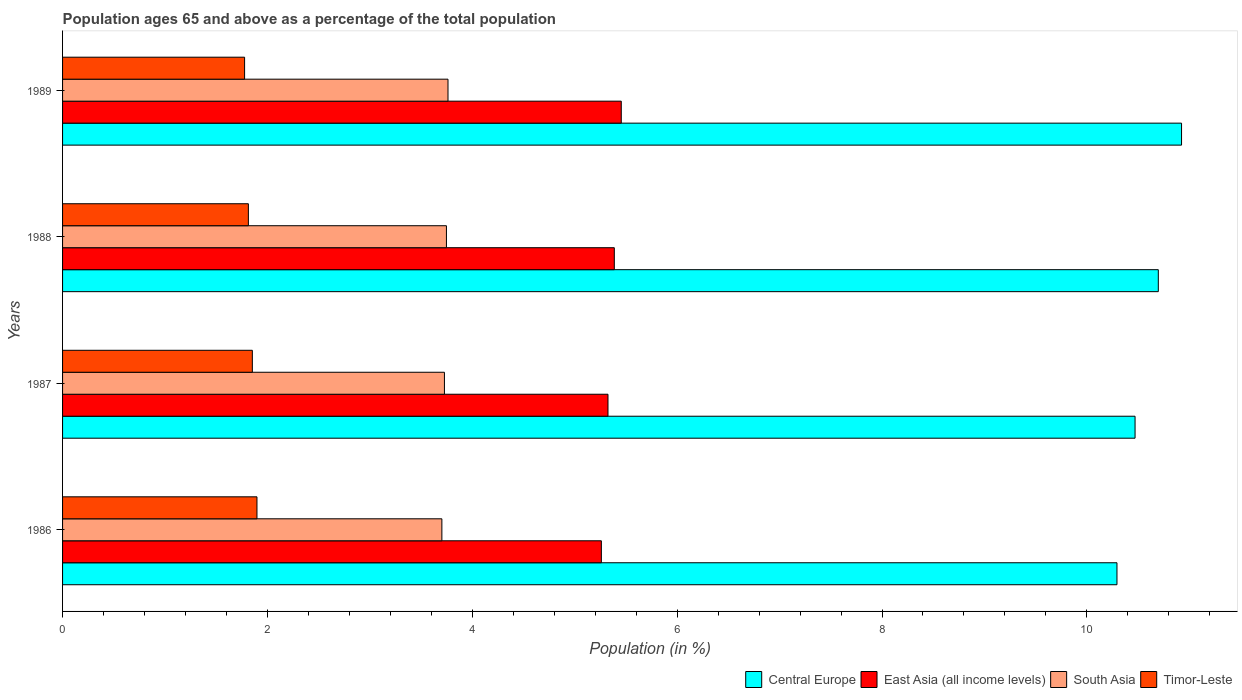How many groups of bars are there?
Your answer should be very brief. 4. Are the number of bars per tick equal to the number of legend labels?
Your response must be concise. Yes. Are the number of bars on each tick of the Y-axis equal?
Offer a very short reply. Yes. How many bars are there on the 2nd tick from the bottom?
Offer a terse response. 4. In how many cases, is the number of bars for a given year not equal to the number of legend labels?
Keep it short and to the point. 0. What is the percentage of the population ages 65 and above in Central Europe in 1988?
Offer a terse response. 10.7. Across all years, what is the maximum percentage of the population ages 65 and above in East Asia (all income levels)?
Your answer should be compact. 5.45. Across all years, what is the minimum percentage of the population ages 65 and above in South Asia?
Ensure brevity in your answer.  3.7. What is the total percentage of the population ages 65 and above in South Asia in the graph?
Provide a succinct answer. 14.94. What is the difference between the percentage of the population ages 65 and above in Central Europe in 1988 and that in 1989?
Offer a very short reply. -0.23. What is the difference between the percentage of the population ages 65 and above in South Asia in 1988 and the percentage of the population ages 65 and above in East Asia (all income levels) in 1986?
Ensure brevity in your answer.  -1.51. What is the average percentage of the population ages 65 and above in Central Europe per year?
Offer a very short reply. 10.6. In the year 1987, what is the difference between the percentage of the population ages 65 and above in South Asia and percentage of the population ages 65 and above in Central Europe?
Your response must be concise. -6.74. In how many years, is the percentage of the population ages 65 and above in East Asia (all income levels) greater than 6.8 ?
Provide a succinct answer. 0. What is the ratio of the percentage of the population ages 65 and above in East Asia (all income levels) in 1987 to that in 1989?
Give a very brief answer. 0.98. What is the difference between the highest and the second highest percentage of the population ages 65 and above in South Asia?
Your answer should be compact. 0.02. What is the difference between the highest and the lowest percentage of the population ages 65 and above in East Asia (all income levels)?
Keep it short and to the point. 0.19. In how many years, is the percentage of the population ages 65 and above in East Asia (all income levels) greater than the average percentage of the population ages 65 and above in East Asia (all income levels) taken over all years?
Your response must be concise. 2. What does the 1st bar from the bottom in 1987 represents?
Your answer should be very brief. Central Europe. Is it the case that in every year, the sum of the percentage of the population ages 65 and above in South Asia and percentage of the population ages 65 and above in East Asia (all income levels) is greater than the percentage of the population ages 65 and above in Timor-Leste?
Make the answer very short. Yes. How many years are there in the graph?
Provide a succinct answer. 4. What is the difference between two consecutive major ticks on the X-axis?
Ensure brevity in your answer.  2. Does the graph contain grids?
Keep it short and to the point. No. Where does the legend appear in the graph?
Your response must be concise. Bottom right. What is the title of the graph?
Keep it short and to the point. Population ages 65 and above as a percentage of the total population. What is the label or title of the Y-axis?
Keep it short and to the point. Years. What is the Population (in %) in Central Europe in 1986?
Offer a terse response. 10.29. What is the Population (in %) in East Asia (all income levels) in 1986?
Ensure brevity in your answer.  5.26. What is the Population (in %) of South Asia in 1986?
Keep it short and to the point. 3.7. What is the Population (in %) of Timor-Leste in 1986?
Ensure brevity in your answer.  1.9. What is the Population (in %) in Central Europe in 1987?
Offer a very short reply. 10.47. What is the Population (in %) of East Asia (all income levels) in 1987?
Provide a succinct answer. 5.32. What is the Population (in %) of South Asia in 1987?
Your answer should be compact. 3.73. What is the Population (in %) of Timor-Leste in 1987?
Provide a succinct answer. 1.85. What is the Population (in %) of Central Europe in 1988?
Make the answer very short. 10.7. What is the Population (in %) in East Asia (all income levels) in 1988?
Ensure brevity in your answer.  5.39. What is the Population (in %) in South Asia in 1988?
Ensure brevity in your answer.  3.75. What is the Population (in %) in Timor-Leste in 1988?
Give a very brief answer. 1.81. What is the Population (in %) in Central Europe in 1989?
Your response must be concise. 10.92. What is the Population (in %) in East Asia (all income levels) in 1989?
Provide a succinct answer. 5.45. What is the Population (in %) in South Asia in 1989?
Offer a terse response. 3.76. What is the Population (in %) in Timor-Leste in 1989?
Keep it short and to the point. 1.78. Across all years, what is the maximum Population (in %) in Central Europe?
Provide a short and direct response. 10.92. Across all years, what is the maximum Population (in %) of East Asia (all income levels)?
Provide a short and direct response. 5.45. Across all years, what is the maximum Population (in %) in South Asia?
Make the answer very short. 3.76. Across all years, what is the maximum Population (in %) in Timor-Leste?
Offer a terse response. 1.9. Across all years, what is the minimum Population (in %) of Central Europe?
Make the answer very short. 10.29. Across all years, what is the minimum Population (in %) of East Asia (all income levels)?
Your response must be concise. 5.26. Across all years, what is the minimum Population (in %) of South Asia?
Make the answer very short. 3.7. Across all years, what is the minimum Population (in %) of Timor-Leste?
Your response must be concise. 1.78. What is the total Population (in %) of Central Europe in the graph?
Give a very brief answer. 42.39. What is the total Population (in %) in East Asia (all income levels) in the graph?
Your answer should be very brief. 21.43. What is the total Population (in %) in South Asia in the graph?
Give a very brief answer. 14.94. What is the total Population (in %) of Timor-Leste in the graph?
Provide a short and direct response. 7.34. What is the difference between the Population (in %) of Central Europe in 1986 and that in 1987?
Offer a terse response. -0.18. What is the difference between the Population (in %) of East Asia (all income levels) in 1986 and that in 1987?
Offer a very short reply. -0.06. What is the difference between the Population (in %) of South Asia in 1986 and that in 1987?
Your response must be concise. -0.03. What is the difference between the Population (in %) in Timor-Leste in 1986 and that in 1987?
Offer a terse response. 0.05. What is the difference between the Population (in %) in Central Europe in 1986 and that in 1988?
Ensure brevity in your answer.  -0.4. What is the difference between the Population (in %) of East Asia (all income levels) in 1986 and that in 1988?
Make the answer very short. -0.13. What is the difference between the Population (in %) of South Asia in 1986 and that in 1988?
Make the answer very short. -0.04. What is the difference between the Population (in %) in Timor-Leste in 1986 and that in 1988?
Provide a short and direct response. 0.08. What is the difference between the Population (in %) in Central Europe in 1986 and that in 1989?
Provide a succinct answer. -0.63. What is the difference between the Population (in %) in East Asia (all income levels) in 1986 and that in 1989?
Offer a terse response. -0.19. What is the difference between the Population (in %) in South Asia in 1986 and that in 1989?
Your response must be concise. -0.06. What is the difference between the Population (in %) in Timor-Leste in 1986 and that in 1989?
Offer a very short reply. 0.12. What is the difference between the Population (in %) of Central Europe in 1987 and that in 1988?
Provide a succinct answer. -0.23. What is the difference between the Population (in %) in East Asia (all income levels) in 1987 and that in 1988?
Offer a very short reply. -0.06. What is the difference between the Population (in %) in South Asia in 1987 and that in 1988?
Provide a short and direct response. -0.02. What is the difference between the Population (in %) of Timor-Leste in 1987 and that in 1988?
Your response must be concise. 0.04. What is the difference between the Population (in %) in Central Europe in 1987 and that in 1989?
Offer a very short reply. -0.45. What is the difference between the Population (in %) of East Asia (all income levels) in 1987 and that in 1989?
Provide a short and direct response. -0.13. What is the difference between the Population (in %) of South Asia in 1987 and that in 1989?
Give a very brief answer. -0.03. What is the difference between the Population (in %) in Timor-Leste in 1987 and that in 1989?
Offer a terse response. 0.08. What is the difference between the Population (in %) of Central Europe in 1988 and that in 1989?
Keep it short and to the point. -0.23. What is the difference between the Population (in %) of East Asia (all income levels) in 1988 and that in 1989?
Provide a succinct answer. -0.07. What is the difference between the Population (in %) of South Asia in 1988 and that in 1989?
Ensure brevity in your answer.  -0.02. What is the difference between the Population (in %) of Timor-Leste in 1988 and that in 1989?
Provide a succinct answer. 0.04. What is the difference between the Population (in %) in Central Europe in 1986 and the Population (in %) in East Asia (all income levels) in 1987?
Provide a succinct answer. 4.97. What is the difference between the Population (in %) of Central Europe in 1986 and the Population (in %) of South Asia in 1987?
Provide a short and direct response. 6.57. What is the difference between the Population (in %) in Central Europe in 1986 and the Population (in %) in Timor-Leste in 1987?
Your response must be concise. 8.44. What is the difference between the Population (in %) of East Asia (all income levels) in 1986 and the Population (in %) of South Asia in 1987?
Make the answer very short. 1.53. What is the difference between the Population (in %) in East Asia (all income levels) in 1986 and the Population (in %) in Timor-Leste in 1987?
Give a very brief answer. 3.41. What is the difference between the Population (in %) in South Asia in 1986 and the Population (in %) in Timor-Leste in 1987?
Offer a terse response. 1.85. What is the difference between the Population (in %) of Central Europe in 1986 and the Population (in %) of East Asia (all income levels) in 1988?
Keep it short and to the point. 4.91. What is the difference between the Population (in %) of Central Europe in 1986 and the Population (in %) of South Asia in 1988?
Your response must be concise. 6.55. What is the difference between the Population (in %) of Central Europe in 1986 and the Population (in %) of Timor-Leste in 1988?
Provide a succinct answer. 8.48. What is the difference between the Population (in %) in East Asia (all income levels) in 1986 and the Population (in %) in South Asia in 1988?
Give a very brief answer. 1.51. What is the difference between the Population (in %) of East Asia (all income levels) in 1986 and the Population (in %) of Timor-Leste in 1988?
Give a very brief answer. 3.45. What is the difference between the Population (in %) of South Asia in 1986 and the Population (in %) of Timor-Leste in 1988?
Keep it short and to the point. 1.89. What is the difference between the Population (in %) in Central Europe in 1986 and the Population (in %) in East Asia (all income levels) in 1989?
Give a very brief answer. 4.84. What is the difference between the Population (in %) of Central Europe in 1986 and the Population (in %) of South Asia in 1989?
Offer a terse response. 6.53. What is the difference between the Population (in %) of Central Europe in 1986 and the Population (in %) of Timor-Leste in 1989?
Offer a very short reply. 8.52. What is the difference between the Population (in %) of East Asia (all income levels) in 1986 and the Population (in %) of South Asia in 1989?
Keep it short and to the point. 1.5. What is the difference between the Population (in %) in East Asia (all income levels) in 1986 and the Population (in %) in Timor-Leste in 1989?
Your answer should be very brief. 3.48. What is the difference between the Population (in %) in South Asia in 1986 and the Population (in %) in Timor-Leste in 1989?
Give a very brief answer. 1.93. What is the difference between the Population (in %) of Central Europe in 1987 and the Population (in %) of East Asia (all income levels) in 1988?
Give a very brief answer. 5.08. What is the difference between the Population (in %) of Central Europe in 1987 and the Population (in %) of South Asia in 1988?
Offer a very short reply. 6.72. What is the difference between the Population (in %) of Central Europe in 1987 and the Population (in %) of Timor-Leste in 1988?
Your answer should be very brief. 8.66. What is the difference between the Population (in %) in East Asia (all income levels) in 1987 and the Population (in %) in South Asia in 1988?
Provide a short and direct response. 1.58. What is the difference between the Population (in %) in East Asia (all income levels) in 1987 and the Population (in %) in Timor-Leste in 1988?
Provide a short and direct response. 3.51. What is the difference between the Population (in %) in South Asia in 1987 and the Population (in %) in Timor-Leste in 1988?
Give a very brief answer. 1.91. What is the difference between the Population (in %) in Central Europe in 1987 and the Population (in %) in East Asia (all income levels) in 1989?
Ensure brevity in your answer.  5.02. What is the difference between the Population (in %) of Central Europe in 1987 and the Population (in %) of South Asia in 1989?
Ensure brevity in your answer.  6.71. What is the difference between the Population (in %) in Central Europe in 1987 and the Population (in %) in Timor-Leste in 1989?
Your response must be concise. 8.69. What is the difference between the Population (in %) of East Asia (all income levels) in 1987 and the Population (in %) of South Asia in 1989?
Give a very brief answer. 1.56. What is the difference between the Population (in %) in East Asia (all income levels) in 1987 and the Population (in %) in Timor-Leste in 1989?
Keep it short and to the point. 3.55. What is the difference between the Population (in %) of South Asia in 1987 and the Population (in %) of Timor-Leste in 1989?
Offer a very short reply. 1.95. What is the difference between the Population (in %) of Central Europe in 1988 and the Population (in %) of East Asia (all income levels) in 1989?
Your response must be concise. 5.24. What is the difference between the Population (in %) of Central Europe in 1988 and the Population (in %) of South Asia in 1989?
Offer a very short reply. 6.93. What is the difference between the Population (in %) in Central Europe in 1988 and the Population (in %) in Timor-Leste in 1989?
Offer a terse response. 8.92. What is the difference between the Population (in %) in East Asia (all income levels) in 1988 and the Population (in %) in South Asia in 1989?
Your answer should be compact. 1.62. What is the difference between the Population (in %) in East Asia (all income levels) in 1988 and the Population (in %) in Timor-Leste in 1989?
Keep it short and to the point. 3.61. What is the difference between the Population (in %) of South Asia in 1988 and the Population (in %) of Timor-Leste in 1989?
Keep it short and to the point. 1.97. What is the average Population (in %) of Central Europe per year?
Give a very brief answer. 10.6. What is the average Population (in %) of East Asia (all income levels) per year?
Provide a short and direct response. 5.36. What is the average Population (in %) of South Asia per year?
Offer a very short reply. 3.74. What is the average Population (in %) in Timor-Leste per year?
Offer a terse response. 1.84. In the year 1986, what is the difference between the Population (in %) of Central Europe and Population (in %) of East Asia (all income levels)?
Your answer should be compact. 5.03. In the year 1986, what is the difference between the Population (in %) of Central Europe and Population (in %) of South Asia?
Your response must be concise. 6.59. In the year 1986, what is the difference between the Population (in %) in Central Europe and Population (in %) in Timor-Leste?
Keep it short and to the point. 8.4. In the year 1986, what is the difference between the Population (in %) in East Asia (all income levels) and Population (in %) in South Asia?
Offer a terse response. 1.56. In the year 1986, what is the difference between the Population (in %) of East Asia (all income levels) and Population (in %) of Timor-Leste?
Your answer should be compact. 3.36. In the year 1986, what is the difference between the Population (in %) in South Asia and Population (in %) in Timor-Leste?
Your answer should be compact. 1.81. In the year 1987, what is the difference between the Population (in %) of Central Europe and Population (in %) of East Asia (all income levels)?
Offer a terse response. 5.15. In the year 1987, what is the difference between the Population (in %) of Central Europe and Population (in %) of South Asia?
Your response must be concise. 6.74. In the year 1987, what is the difference between the Population (in %) in Central Europe and Population (in %) in Timor-Leste?
Your answer should be very brief. 8.62. In the year 1987, what is the difference between the Population (in %) in East Asia (all income levels) and Population (in %) in South Asia?
Your answer should be very brief. 1.6. In the year 1987, what is the difference between the Population (in %) of East Asia (all income levels) and Population (in %) of Timor-Leste?
Provide a succinct answer. 3.47. In the year 1987, what is the difference between the Population (in %) in South Asia and Population (in %) in Timor-Leste?
Keep it short and to the point. 1.88. In the year 1988, what is the difference between the Population (in %) in Central Europe and Population (in %) in East Asia (all income levels)?
Your answer should be compact. 5.31. In the year 1988, what is the difference between the Population (in %) in Central Europe and Population (in %) in South Asia?
Offer a very short reply. 6.95. In the year 1988, what is the difference between the Population (in %) in Central Europe and Population (in %) in Timor-Leste?
Make the answer very short. 8.88. In the year 1988, what is the difference between the Population (in %) in East Asia (all income levels) and Population (in %) in South Asia?
Keep it short and to the point. 1.64. In the year 1988, what is the difference between the Population (in %) in East Asia (all income levels) and Population (in %) in Timor-Leste?
Keep it short and to the point. 3.57. In the year 1988, what is the difference between the Population (in %) in South Asia and Population (in %) in Timor-Leste?
Your answer should be very brief. 1.93. In the year 1989, what is the difference between the Population (in %) in Central Europe and Population (in %) in East Asia (all income levels)?
Provide a short and direct response. 5.47. In the year 1989, what is the difference between the Population (in %) in Central Europe and Population (in %) in South Asia?
Offer a very short reply. 7.16. In the year 1989, what is the difference between the Population (in %) of Central Europe and Population (in %) of Timor-Leste?
Offer a very short reply. 9.15. In the year 1989, what is the difference between the Population (in %) of East Asia (all income levels) and Population (in %) of South Asia?
Your response must be concise. 1.69. In the year 1989, what is the difference between the Population (in %) of East Asia (all income levels) and Population (in %) of Timor-Leste?
Give a very brief answer. 3.68. In the year 1989, what is the difference between the Population (in %) in South Asia and Population (in %) in Timor-Leste?
Keep it short and to the point. 1.99. What is the ratio of the Population (in %) in Central Europe in 1986 to that in 1987?
Give a very brief answer. 0.98. What is the ratio of the Population (in %) of East Asia (all income levels) in 1986 to that in 1987?
Give a very brief answer. 0.99. What is the ratio of the Population (in %) in Timor-Leste in 1986 to that in 1987?
Keep it short and to the point. 1.02. What is the ratio of the Population (in %) of Central Europe in 1986 to that in 1988?
Give a very brief answer. 0.96. What is the ratio of the Population (in %) of East Asia (all income levels) in 1986 to that in 1988?
Your answer should be compact. 0.98. What is the ratio of the Population (in %) of Timor-Leste in 1986 to that in 1988?
Keep it short and to the point. 1.05. What is the ratio of the Population (in %) of Central Europe in 1986 to that in 1989?
Provide a succinct answer. 0.94. What is the ratio of the Population (in %) of East Asia (all income levels) in 1986 to that in 1989?
Your answer should be compact. 0.96. What is the ratio of the Population (in %) in South Asia in 1986 to that in 1989?
Make the answer very short. 0.98. What is the ratio of the Population (in %) of Timor-Leste in 1986 to that in 1989?
Provide a short and direct response. 1.07. What is the ratio of the Population (in %) of Central Europe in 1987 to that in 1988?
Offer a terse response. 0.98. What is the ratio of the Population (in %) in East Asia (all income levels) in 1987 to that in 1988?
Provide a short and direct response. 0.99. What is the ratio of the Population (in %) in South Asia in 1987 to that in 1988?
Give a very brief answer. 0.99. What is the ratio of the Population (in %) in Timor-Leste in 1987 to that in 1988?
Give a very brief answer. 1.02. What is the ratio of the Population (in %) in Central Europe in 1987 to that in 1989?
Make the answer very short. 0.96. What is the ratio of the Population (in %) in East Asia (all income levels) in 1987 to that in 1989?
Keep it short and to the point. 0.98. What is the ratio of the Population (in %) of South Asia in 1987 to that in 1989?
Your answer should be compact. 0.99. What is the ratio of the Population (in %) in Timor-Leste in 1987 to that in 1989?
Your answer should be compact. 1.04. What is the ratio of the Population (in %) of Central Europe in 1988 to that in 1989?
Provide a short and direct response. 0.98. What is the ratio of the Population (in %) of East Asia (all income levels) in 1988 to that in 1989?
Your answer should be very brief. 0.99. What is the ratio of the Population (in %) in South Asia in 1988 to that in 1989?
Offer a very short reply. 1. What is the ratio of the Population (in %) in Timor-Leste in 1988 to that in 1989?
Provide a succinct answer. 1.02. What is the difference between the highest and the second highest Population (in %) in Central Europe?
Offer a terse response. 0.23. What is the difference between the highest and the second highest Population (in %) of East Asia (all income levels)?
Make the answer very short. 0.07. What is the difference between the highest and the second highest Population (in %) in South Asia?
Offer a very short reply. 0.02. What is the difference between the highest and the second highest Population (in %) in Timor-Leste?
Offer a terse response. 0.05. What is the difference between the highest and the lowest Population (in %) in Central Europe?
Ensure brevity in your answer.  0.63. What is the difference between the highest and the lowest Population (in %) in East Asia (all income levels)?
Make the answer very short. 0.19. What is the difference between the highest and the lowest Population (in %) in South Asia?
Provide a succinct answer. 0.06. What is the difference between the highest and the lowest Population (in %) in Timor-Leste?
Your answer should be compact. 0.12. 